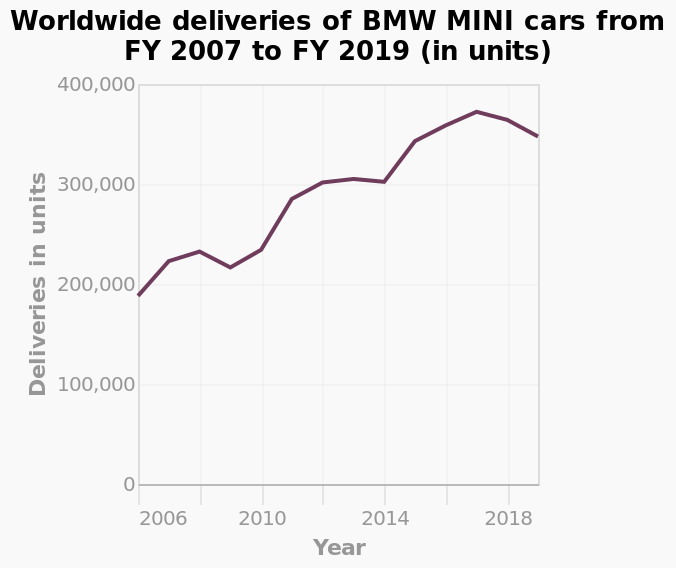<image>
What is the minimum and maximum value shown on the y-axis? The minimum value shown on the y-axis is 0 units and the maximum value is 400,000 units. Is the scale used on the y-axis linear or logarithmic? The scale used on the y-axis is linear. Which year had the lowest volume of worldwide deliveries for BMW?  The year 2006 had the lowest volume of worldwide deliveries for BMW. 